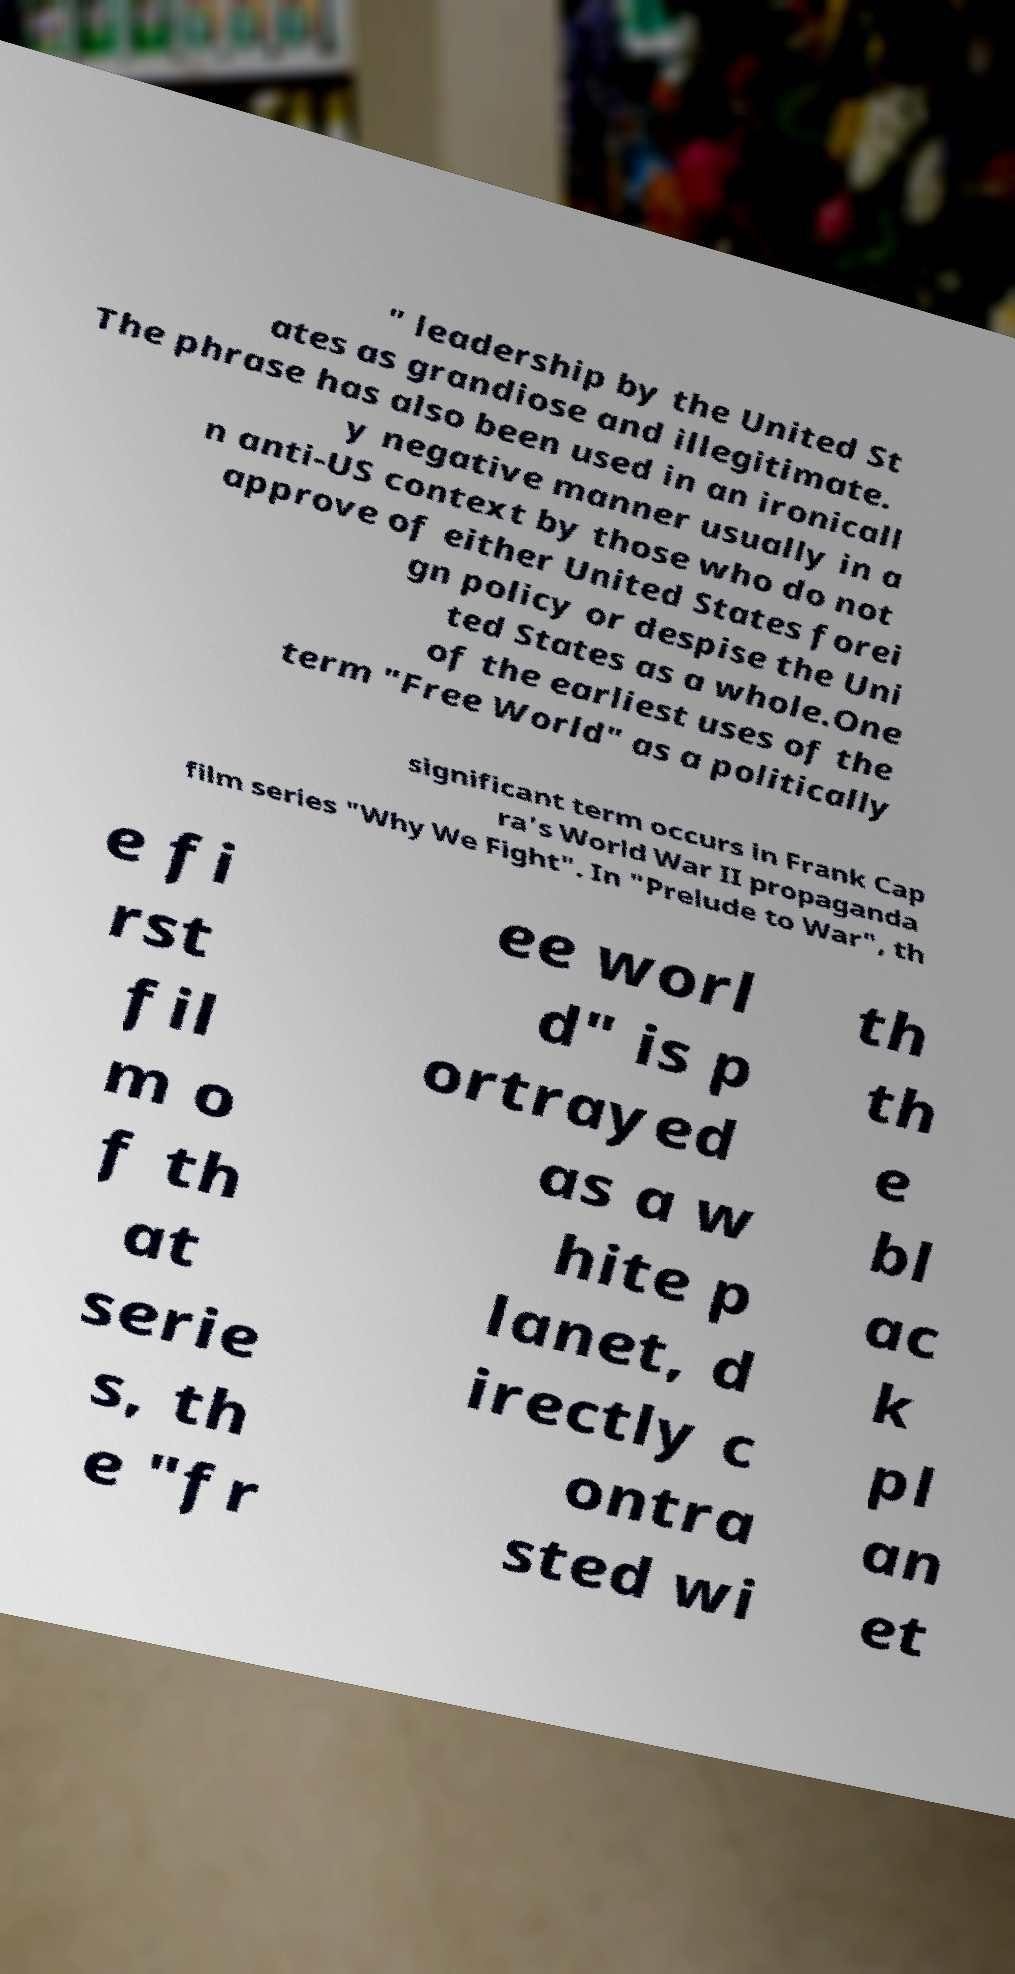Can you read and provide the text displayed in the image?This photo seems to have some interesting text. Can you extract and type it out for me? " leadership by the United St ates as grandiose and illegitimate. The phrase has also been used in an ironicall y negative manner usually in a n anti-US context by those who do not approve of either United States forei gn policy or despise the Uni ted States as a whole.One of the earliest uses of the term "Free World" as a politically significant term occurs in Frank Cap ra's World War II propaganda film series "Why We Fight". In "Prelude to War", th e fi rst fil m o f th at serie s, th e "fr ee worl d" is p ortrayed as a w hite p lanet, d irectly c ontra sted wi th th e bl ac k pl an et 